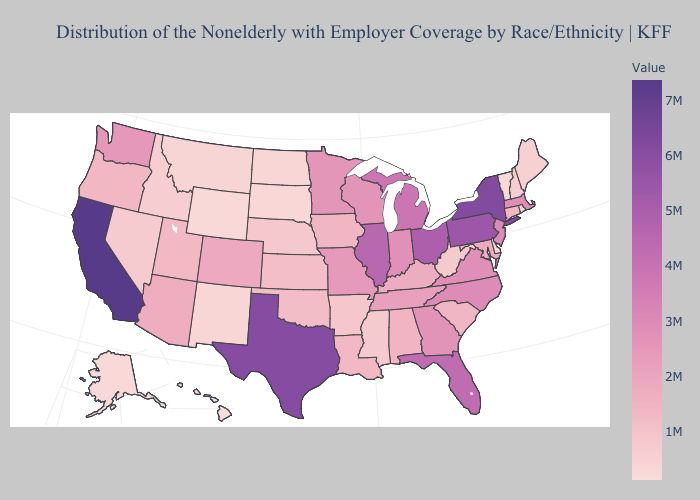Which states have the lowest value in the USA?
Give a very brief answer. Hawaii. Does Nebraska have the highest value in the USA?
Write a very short answer. No. Does Ohio have the highest value in the MidWest?
Keep it brief. Yes. Does Alaska have the lowest value in the USA?
Keep it brief. No. Among the states that border Michigan , which have the highest value?
Quick response, please. Ohio. 